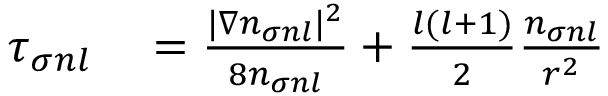Convert formula to latex. <formula><loc_0><loc_0><loc_500><loc_500>\begin{array} { r l } { \tau _ { \sigma n l } } & = \frac { | \nabla n _ { \sigma n l } | ^ { 2 } } { 8 n _ { \sigma n l } } + \frac { l ( l + 1 ) } { 2 } \frac { n _ { \sigma n l } } { r ^ { 2 } } } \end{array}</formula> 